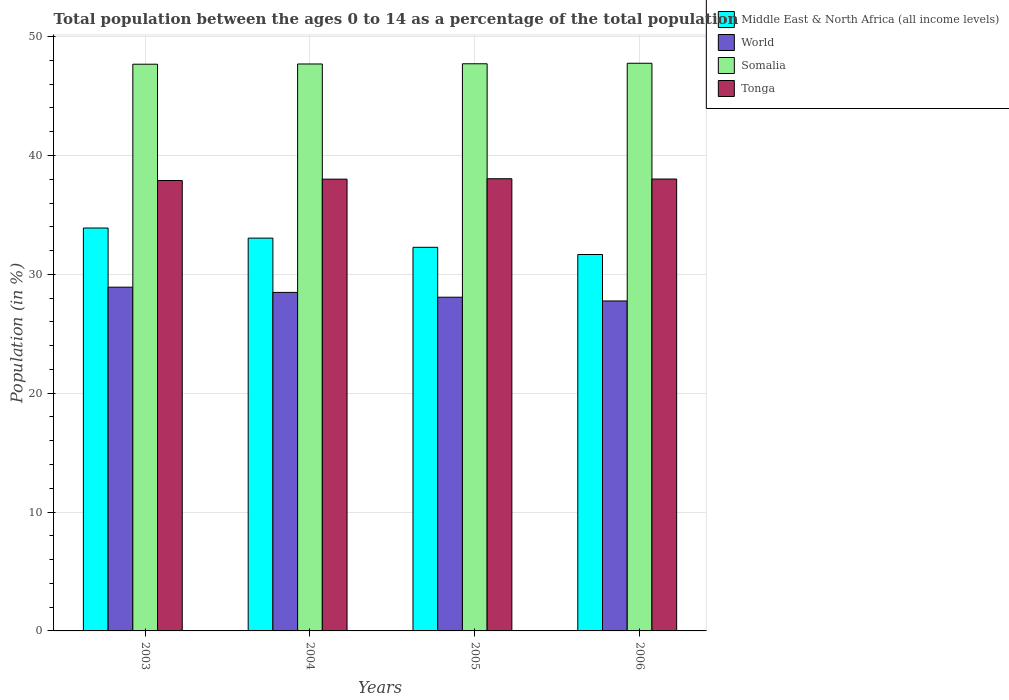How many different coloured bars are there?
Offer a very short reply. 4. How many bars are there on the 3rd tick from the right?
Offer a terse response. 4. What is the label of the 1st group of bars from the left?
Provide a succinct answer. 2003. In how many cases, is the number of bars for a given year not equal to the number of legend labels?
Your answer should be compact. 0. What is the percentage of the population ages 0 to 14 in World in 2003?
Provide a succinct answer. 28.92. Across all years, what is the maximum percentage of the population ages 0 to 14 in Somalia?
Provide a succinct answer. 47.76. Across all years, what is the minimum percentage of the population ages 0 to 14 in World?
Your answer should be compact. 27.76. In which year was the percentage of the population ages 0 to 14 in Tonga maximum?
Your answer should be compact. 2005. What is the total percentage of the population ages 0 to 14 in Tonga in the graph?
Your answer should be compact. 151.97. What is the difference between the percentage of the population ages 0 to 14 in Somalia in 2005 and that in 2006?
Your answer should be compact. -0.04. What is the difference between the percentage of the population ages 0 to 14 in Tonga in 2003 and the percentage of the population ages 0 to 14 in Middle East & North Africa (all income levels) in 2006?
Your response must be concise. 6.23. What is the average percentage of the population ages 0 to 14 in Tonga per year?
Provide a short and direct response. 37.99. In the year 2005, what is the difference between the percentage of the population ages 0 to 14 in World and percentage of the population ages 0 to 14 in Somalia?
Your answer should be compact. -19.64. In how many years, is the percentage of the population ages 0 to 14 in Somalia greater than 20?
Your answer should be compact. 4. What is the ratio of the percentage of the population ages 0 to 14 in Middle East & North Africa (all income levels) in 2003 to that in 2005?
Your answer should be compact. 1.05. What is the difference between the highest and the second highest percentage of the population ages 0 to 14 in Somalia?
Your response must be concise. 0.04. What is the difference between the highest and the lowest percentage of the population ages 0 to 14 in Middle East & North Africa (all income levels)?
Give a very brief answer. 2.23. What does the 4th bar from the left in 2006 represents?
Make the answer very short. Tonga. What does the 2nd bar from the right in 2003 represents?
Give a very brief answer. Somalia. How many years are there in the graph?
Make the answer very short. 4. What is the difference between two consecutive major ticks on the Y-axis?
Offer a terse response. 10. Are the values on the major ticks of Y-axis written in scientific E-notation?
Your response must be concise. No. Does the graph contain any zero values?
Offer a terse response. No. Does the graph contain grids?
Make the answer very short. Yes. How many legend labels are there?
Ensure brevity in your answer.  4. How are the legend labels stacked?
Offer a very short reply. Vertical. What is the title of the graph?
Your answer should be very brief. Total population between the ages 0 to 14 as a percentage of the total population. What is the label or title of the X-axis?
Make the answer very short. Years. What is the label or title of the Y-axis?
Your answer should be very brief. Population (in %). What is the Population (in %) in Middle East & North Africa (all income levels) in 2003?
Provide a short and direct response. 33.9. What is the Population (in %) of World in 2003?
Your answer should be compact. 28.92. What is the Population (in %) in Somalia in 2003?
Give a very brief answer. 47.68. What is the Population (in %) of Tonga in 2003?
Make the answer very short. 37.9. What is the Population (in %) in Middle East & North Africa (all income levels) in 2004?
Ensure brevity in your answer.  33.05. What is the Population (in %) in World in 2004?
Give a very brief answer. 28.48. What is the Population (in %) of Somalia in 2004?
Your answer should be very brief. 47.7. What is the Population (in %) in Tonga in 2004?
Make the answer very short. 38.01. What is the Population (in %) in Middle East & North Africa (all income levels) in 2005?
Offer a terse response. 32.28. What is the Population (in %) in World in 2005?
Give a very brief answer. 28.08. What is the Population (in %) of Somalia in 2005?
Your answer should be very brief. 47.72. What is the Population (in %) in Tonga in 2005?
Provide a short and direct response. 38.04. What is the Population (in %) of Middle East & North Africa (all income levels) in 2006?
Your answer should be compact. 31.67. What is the Population (in %) in World in 2006?
Offer a very short reply. 27.76. What is the Population (in %) in Somalia in 2006?
Keep it short and to the point. 47.76. What is the Population (in %) in Tonga in 2006?
Provide a succinct answer. 38.02. Across all years, what is the maximum Population (in %) in Middle East & North Africa (all income levels)?
Give a very brief answer. 33.9. Across all years, what is the maximum Population (in %) in World?
Provide a succinct answer. 28.92. Across all years, what is the maximum Population (in %) in Somalia?
Offer a very short reply. 47.76. Across all years, what is the maximum Population (in %) of Tonga?
Offer a terse response. 38.04. Across all years, what is the minimum Population (in %) in Middle East & North Africa (all income levels)?
Provide a succinct answer. 31.67. Across all years, what is the minimum Population (in %) in World?
Offer a terse response. 27.76. Across all years, what is the minimum Population (in %) in Somalia?
Your answer should be very brief. 47.68. Across all years, what is the minimum Population (in %) in Tonga?
Offer a terse response. 37.9. What is the total Population (in %) in Middle East & North Africa (all income levels) in the graph?
Offer a terse response. 130.89. What is the total Population (in %) in World in the graph?
Ensure brevity in your answer.  113.24. What is the total Population (in %) of Somalia in the graph?
Ensure brevity in your answer.  190.85. What is the total Population (in %) of Tonga in the graph?
Offer a terse response. 151.97. What is the difference between the Population (in %) in Middle East & North Africa (all income levels) in 2003 and that in 2004?
Provide a succinct answer. 0.85. What is the difference between the Population (in %) in World in 2003 and that in 2004?
Keep it short and to the point. 0.44. What is the difference between the Population (in %) of Somalia in 2003 and that in 2004?
Your answer should be very brief. -0.02. What is the difference between the Population (in %) in Tonga in 2003 and that in 2004?
Ensure brevity in your answer.  -0.11. What is the difference between the Population (in %) in Middle East & North Africa (all income levels) in 2003 and that in 2005?
Your answer should be compact. 1.62. What is the difference between the Population (in %) of World in 2003 and that in 2005?
Make the answer very short. 0.84. What is the difference between the Population (in %) of Somalia in 2003 and that in 2005?
Provide a succinct answer. -0.04. What is the difference between the Population (in %) of Tonga in 2003 and that in 2005?
Offer a very short reply. -0.15. What is the difference between the Population (in %) of Middle East & North Africa (all income levels) in 2003 and that in 2006?
Offer a terse response. 2.23. What is the difference between the Population (in %) in World in 2003 and that in 2006?
Your answer should be very brief. 1.16. What is the difference between the Population (in %) in Somalia in 2003 and that in 2006?
Make the answer very short. -0.08. What is the difference between the Population (in %) in Tonga in 2003 and that in 2006?
Keep it short and to the point. -0.12. What is the difference between the Population (in %) of Middle East & North Africa (all income levels) in 2004 and that in 2005?
Your answer should be very brief. 0.77. What is the difference between the Population (in %) of World in 2004 and that in 2005?
Keep it short and to the point. 0.41. What is the difference between the Population (in %) in Somalia in 2004 and that in 2005?
Ensure brevity in your answer.  -0.02. What is the difference between the Population (in %) of Tonga in 2004 and that in 2005?
Provide a succinct answer. -0.03. What is the difference between the Population (in %) of Middle East & North Africa (all income levels) in 2004 and that in 2006?
Keep it short and to the point. 1.38. What is the difference between the Population (in %) of World in 2004 and that in 2006?
Keep it short and to the point. 0.72. What is the difference between the Population (in %) of Somalia in 2004 and that in 2006?
Your response must be concise. -0.06. What is the difference between the Population (in %) of Tonga in 2004 and that in 2006?
Offer a very short reply. -0.01. What is the difference between the Population (in %) of Middle East & North Africa (all income levels) in 2005 and that in 2006?
Your answer should be compact. 0.61. What is the difference between the Population (in %) of World in 2005 and that in 2006?
Your answer should be very brief. 0.32. What is the difference between the Population (in %) of Somalia in 2005 and that in 2006?
Offer a terse response. -0.04. What is the difference between the Population (in %) of Tonga in 2005 and that in 2006?
Give a very brief answer. 0.02. What is the difference between the Population (in %) in Middle East & North Africa (all income levels) in 2003 and the Population (in %) in World in 2004?
Provide a short and direct response. 5.42. What is the difference between the Population (in %) in Middle East & North Africa (all income levels) in 2003 and the Population (in %) in Somalia in 2004?
Ensure brevity in your answer.  -13.8. What is the difference between the Population (in %) of Middle East & North Africa (all income levels) in 2003 and the Population (in %) of Tonga in 2004?
Give a very brief answer. -4.11. What is the difference between the Population (in %) of World in 2003 and the Population (in %) of Somalia in 2004?
Offer a terse response. -18.78. What is the difference between the Population (in %) in World in 2003 and the Population (in %) in Tonga in 2004?
Provide a succinct answer. -9.09. What is the difference between the Population (in %) in Somalia in 2003 and the Population (in %) in Tonga in 2004?
Provide a succinct answer. 9.67. What is the difference between the Population (in %) in Middle East & North Africa (all income levels) in 2003 and the Population (in %) in World in 2005?
Provide a short and direct response. 5.82. What is the difference between the Population (in %) in Middle East & North Africa (all income levels) in 2003 and the Population (in %) in Somalia in 2005?
Your answer should be very brief. -13.82. What is the difference between the Population (in %) in Middle East & North Africa (all income levels) in 2003 and the Population (in %) in Tonga in 2005?
Your answer should be compact. -4.15. What is the difference between the Population (in %) in World in 2003 and the Population (in %) in Somalia in 2005?
Offer a very short reply. -18.8. What is the difference between the Population (in %) of World in 2003 and the Population (in %) of Tonga in 2005?
Your answer should be compact. -9.12. What is the difference between the Population (in %) in Somalia in 2003 and the Population (in %) in Tonga in 2005?
Keep it short and to the point. 9.64. What is the difference between the Population (in %) of Middle East & North Africa (all income levels) in 2003 and the Population (in %) of World in 2006?
Provide a short and direct response. 6.14. What is the difference between the Population (in %) of Middle East & North Africa (all income levels) in 2003 and the Population (in %) of Somalia in 2006?
Give a very brief answer. -13.86. What is the difference between the Population (in %) of Middle East & North Africa (all income levels) in 2003 and the Population (in %) of Tonga in 2006?
Make the answer very short. -4.12. What is the difference between the Population (in %) in World in 2003 and the Population (in %) in Somalia in 2006?
Keep it short and to the point. -18.84. What is the difference between the Population (in %) of World in 2003 and the Population (in %) of Tonga in 2006?
Give a very brief answer. -9.1. What is the difference between the Population (in %) of Somalia in 2003 and the Population (in %) of Tonga in 2006?
Give a very brief answer. 9.66. What is the difference between the Population (in %) in Middle East & North Africa (all income levels) in 2004 and the Population (in %) in World in 2005?
Provide a short and direct response. 4.97. What is the difference between the Population (in %) of Middle East & North Africa (all income levels) in 2004 and the Population (in %) of Somalia in 2005?
Make the answer very short. -14.67. What is the difference between the Population (in %) in Middle East & North Africa (all income levels) in 2004 and the Population (in %) in Tonga in 2005?
Keep it short and to the point. -5. What is the difference between the Population (in %) of World in 2004 and the Population (in %) of Somalia in 2005?
Your answer should be very brief. -19.23. What is the difference between the Population (in %) of World in 2004 and the Population (in %) of Tonga in 2005?
Provide a short and direct response. -9.56. What is the difference between the Population (in %) in Somalia in 2004 and the Population (in %) in Tonga in 2005?
Your answer should be very brief. 9.66. What is the difference between the Population (in %) in Middle East & North Africa (all income levels) in 2004 and the Population (in %) in World in 2006?
Provide a succinct answer. 5.29. What is the difference between the Population (in %) in Middle East & North Africa (all income levels) in 2004 and the Population (in %) in Somalia in 2006?
Your response must be concise. -14.71. What is the difference between the Population (in %) of Middle East & North Africa (all income levels) in 2004 and the Population (in %) of Tonga in 2006?
Your response must be concise. -4.97. What is the difference between the Population (in %) of World in 2004 and the Population (in %) of Somalia in 2006?
Ensure brevity in your answer.  -19.28. What is the difference between the Population (in %) in World in 2004 and the Population (in %) in Tonga in 2006?
Provide a short and direct response. -9.54. What is the difference between the Population (in %) of Somalia in 2004 and the Population (in %) of Tonga in 2006?
Provide a short and direct response. 9.68. What is the difference between the Population (in %) of Middle East & North Africa (all income levels) in 2005 and the Population (in %) of World in 2006?
Make the answer very short. 4.52. What is the difference between the Population (in %) in Middle East & North Africa (all income levels) in 2005 and the Population (in %) in Somalia in 2006?
Provide a succinct answer. -15.48. What is the difference between the Population (in %) of Middle East & North Africa (all income levels) in 2005 and the Population (in %) of Tonga in 2006?
Make the answer very short. -5.74. What is the difference between the Population (in %) of World in 2005 and the Population (in %) of Somalia in 2006?
Make the answer very short. -19.68. What is the difference between the Population (in %) in World in 2005 and the Population (in %) in Tonga in 2006?
Offer a very short reply. -9.94. What is the difference between the Population (in %) of Somalia in 2005 and the Population (in %) of Tonga in 2006?
Your response must be concise. 9.7. What is the average Population (in %) in Middle East & North Africa (all income levels) per year?
Provide a succinct answer. 32.72. What is the average Population (in %) in World per year?
Give a very brief answer. 28.31. What is the average Population (in %) in Somalia per year?
Your answer should be compact. 47.71. What is the average Population (in %) in Tonga per year?
Your response must be concise. 37.99. In the year 2003, what is the difference between the Population (in %) of Middle East & North Africa (all income levels) and Population (in %) of World?
Keep it short and to the point. 4.98. In the year 2003, what is the difference between the Population (in %) of Middle East & North Africa (all income levels) and Population (in %) of Somalia?
Provide a short and direct response. -13.78. In the year 2003, what is the difference between the Population (in %) of Middle East & North Africa (all income levels) and Population (in %) of Tonga?
Offer a terse response. -4. In the year 2003, what is the difference between the Population (in %) of World and Population (in %) of Somalia?
Your answer should be very brief. -18.76. In the year 2003, what is the difference between the Population (in %) of World and Population (in %) of Tonga?
Ensure brevity in your answer.  -8.98. In the year 2003, what is the difference between the Population (in %) of Somalia and Population (in %) of Tonga?
Keep it short and to the point. 9.78. In the year 2004, what is the difference between the Population (in %) in Middle East & North Africa (all income levels) and Population (in %) in World?
Your answer should be compact. 4.57. In the year 2004, what is the difference between the Population (in %) of Middle East & North Africa (all income levels) and Population (in %) of Somalia?
Your answer should be compact. -14.65. In the year 2004, what is the difference between the Population (in %) of Middle East & North Africa (all income levels) and Population (in %) of Tonga?
Offer a very short reply. -4.96. In the year 2004, what is the difference between the Population (in %) of World and Population (in %) of Somalia?
Give a very brief answer. -19.22. In the year 2004, what is the difference between the Population (in %) of World and Population (in %) of Tonga?
Your answer should be compact. -9.53. In the year 2004, what is the difference between the Population (in %) of Somalia and Population (in %) of Tonga?
Provide a succinct answer. 9.69. In the year 2005, what is the difference between the Population (in %) in Middle East & North Africa (all income levels) and Population (in %) in World?
Provide a succinct answer. 4.2. In the year 2005, what is the difference between the Population (in %) of Middle East & North Africa (all income levels) and Population (in %) of Somalia?
Your answer should be compact. -15.44. In the year 2005, what is the difference between the Population (in %) in Middle East & North Africa (all income levels) and Population (in %) in Tonga?
Ensure brevity in your answer.  -5.77. In the year 2005, what is the difference between the Population (in %) in World and Population (in %) in Somalia?
Your answer should be compact. -19.64. In the year 2005, what is the difference between the Population (in %) of World and Population (in %) of Tonga?
Ensure brevity in your answer.  -9.97. In the year 2005, what is the difference between the Population (in %) in Somalia and Population (in %) in Tonga?
Give a very brief answer. 9.67. In the year 2006, what is the difference between the Population (in %) of Middle East & North Africa (all income levels) and Population (in %) of World?
Your answer should be compact. 3.91. In the year 2006, what is the difference between the Population (in %) in Middle East & North Africa (all income levels) and Population (in %) in Somalia?
Ensure brevity in your answer.  -16.09. In the year 2006, what is the difference between the Population (in %) of Middle East & North Africa (all income levels) and Population (in %) of Tonga?
Your answer should be compact. -6.35. In the year 2006, what is the difference between the Population (in %) of World and Population (in %) of Somalia?
Make the answer very short. -20. In the year 2006, what is the difference between the Population (in %) in World and Population (in %) in Tonga?
Make the answer very short. -10.26. In the year 2006, what is the difference between the Population (in %) in Somalia and Population (in %) in Tonga?
Offer a very short reply. 9.74. What is the ratio of the Population (in %) of Middle East & North Africa (all income levels) in 2003 to that in 2004?
Keep it short and to the point. 1.03. What is the ratio of the Population (in %) of World in 2003 to that in 2004?
Keep it short and to the point. 1.02. What is the ratio of the Population (in %) of Middle East & North Africa (all income levels) in 2003 to that in 2005?
Ensure brevity in your answer.  1.05. What is the ratio of the Population (in %) of World in 2003 to that in 2005?
Give a very brief answer. 1.03. What is the ratio of the Population (in %) in Somalia in 2003 to that in 2005?
Keep it short and to the point. 1. What is the ratio of the Population (in %) in Tonga in 2003 to that in 2005?
Keep it short and to the point. 1. What is the ratio of the Population (in %) in Middle East & North Africa (all income levels) in 2003 to that in 2006?
Provide a short and direct response. 1.07. What is the ratio of the Population (in %) of World in 2003 to that in 2006?
Make the answer very short. 1.04. What is the ratio of the Population (in %) in Middle East & North Africa (all income levels) in 2004 to that in 2005?
Keep it short and to the point. 1.02. What is the ratio of the Population (in %) of World in 2004 to that in 2005?
Offer a terse response. 1.01. What is the ratio of the Population (in %) in Somalia in 2004 to that in 2005?
Your response must be concise. 1. What is the ratio of the Population (in %) of Middle East & North Africa (all income levels) in 2004 to that in 2006?
Give a very brief answer. 1.04. What is the ratio of the Population (in %) in Middle East & North Africa (all income levels) in 2005 to that in 2006?
Make the answer very short. 1.02. What is the ratio of the Population (in %) in World in 2005 to that in 2006?
Provide a short and direct response. 1.01. What is the ratio of the Population (in %) in Somalia in 2005 to that in 2006?
Offer a very short reply. 1. What is the difference between the highest and the second highest Population (in %) in Middle East & North Africa (all income levels)?
Provide a succinct answer. 0.85. What is the difference between the highest and the second highest Population (in %) of World?
Provide a short and direct response. 0.44. What is the difference between the highest and the second highest Population (in %) in Somalia?
Your answer should be compact. 0.04. What is the difference between the highest and the second highest Population (in %) of Tonga?
Provide a succinct answer. 0.02. What is the difference between the highest and the lowest Population (in %) of Middle East & North Africa (all income levels)?
Give a very brief answer. 2.23. What is the difference between the highest and the lowest Population (in %) in World?
Give a very brief answer. 1.16. What is the difference between the highest and the lowest Population (in %) of Somalia?
Your answer should be very brief. 0.08. What is the difference between the highest and the lowest Population (in %) in Tonga?
Your response must be concise. 0.15. 